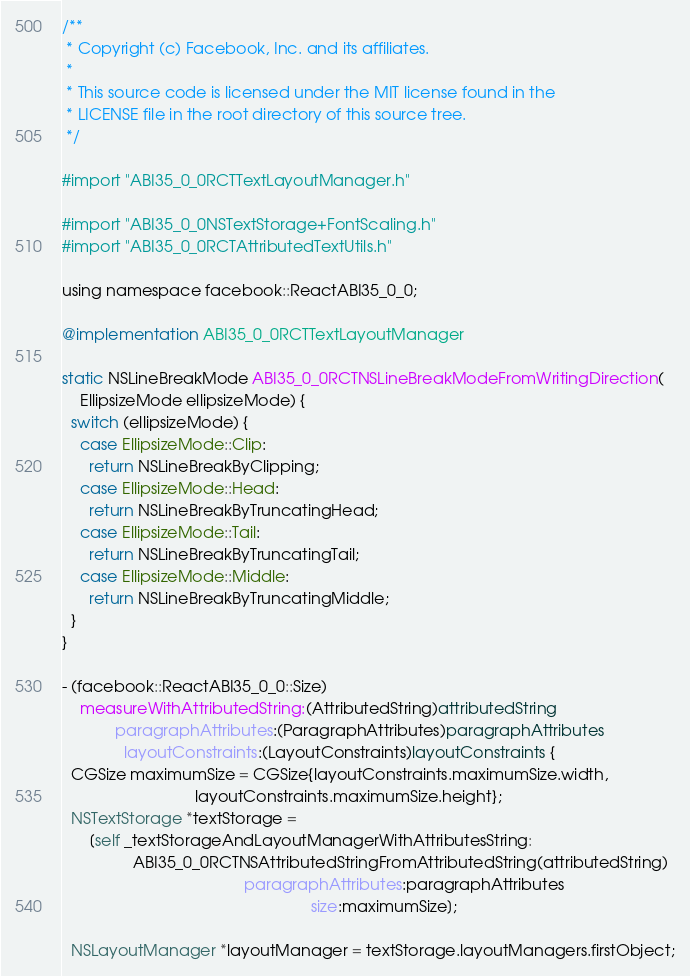Convert code to text. <code><loc_0><loc_0><loc_500><loc_500><_ObjectiveC_>/**
 * Copyright (c) Facebook, Inc. and its affiliates.
 *
 * This source code is licensed under the MIT license found in the
 * LICENSE file in the root directory of this source tree.
 */

#import "ABI35_0_0RCTTextLayoutManager.h"

#import "ABI35_0_0NSTextStorage+FontScaling.h"
#import "ABI35_0_0RCTAttributedTextUtils.h"

using namespace facebook::ReactABI35_0_0;

@implementation ABI35_0_0RCTTextLayoutManager

static NSLineBreakMode ABI35_0_0RCTNSLineBreakModeFromWritingDirection(
    EllipsizeMode ellipsizeMode) {
  switch (ellipsizeMode) {
    case EllipsizeMode::Clip:
      return NSLineBreakByClipping;
    case EllipsizeMode::Head:
      return NSLineBreakByTruncatingHead;
    case EllipsizeMode::Tail:
      return NSLineBreakByTruncatingTail;
    case EllipsizeMode::Middle:
      return NSLineBreakByTruncatingMiddle;
  }
}

- (facebook::ReactABI35_0_0::Size)
    measureWithAttributedString:(AttributedString)attributedString
            paragraphAttributes:(ParagraphAttributes)paragraphAttributes
              layoutConstraints:(LayoutConstraints)layoutConstraints {
  CGSize maximumSize = CGSize{layoutConstraints.maximumSize.width,
                              layoutConstraints.maximumSize.height};
  NSTextStorage *textStorage =
      [self _textStorageAndLayoutManagerWithAttributesString:
                ABI35_0_0RCTNSAttributedStringFromAttributedString(attributedString)
                                         paragraphAttributes:paragraphAttributes
                                                        size:maximumSize];

  NSLayoutManager *layoutManager = textStorage.layoutManagers.firstObject;</code> 